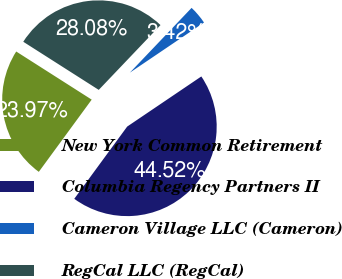<chart> <loc_0><loc_0><loc_500><loc_500><pie_chart><fcel>New York Common Retirement<fcel>Columbia Regency Partners II<fcel>Cameron Village LLC (Cameron)<fcel>RegCal LLC (RegCal)<nl><fcel>23.97%<fcel>44.52%<fcel>3.42%<fcel>28.08%<nl></chart> 